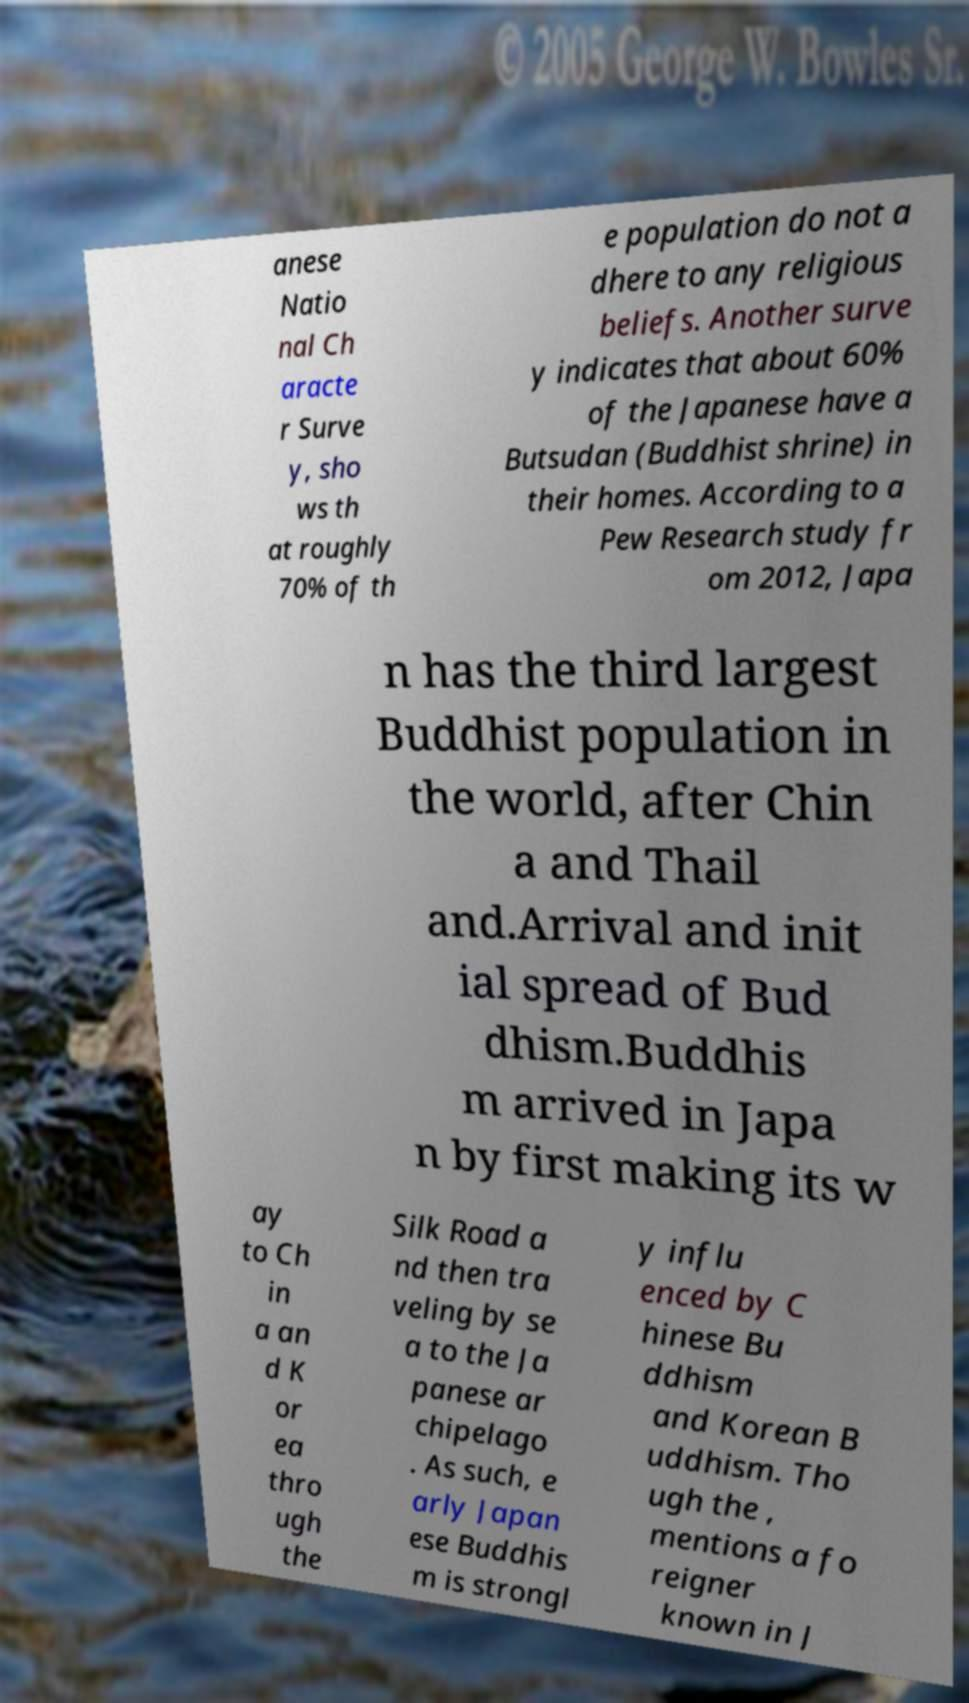There's text embedded in this image that I need extracted. Can you transcribe it verbatim? anese Natio nal Ch aracte r Surve y, sho ws th at roughly 70% of th e population do not a dhere to any religious beliefs. Another surve y indicates that about 60% of the Japanese have a Butsudan (Buddhist shrine) in their homes. According to a Pew Research study fr om 2012, Japa n has the third largest Buddhist population in the world, after Chin a and Thail and.Arrival and init ial spread of Bud dhism.Buddhis m arrived in Japa n by first making its w ay to Ch in a an d K or ea thro ugh the Silk Road a nd then tra veling by se a to the Ja panese ar chipelago . As such, e arly Japan ese Buddhis m is strongl y influ enced by C hinese Bu ddhism and Korean B uddhism. Tho ugh the , mentions a fo reigner known in J 